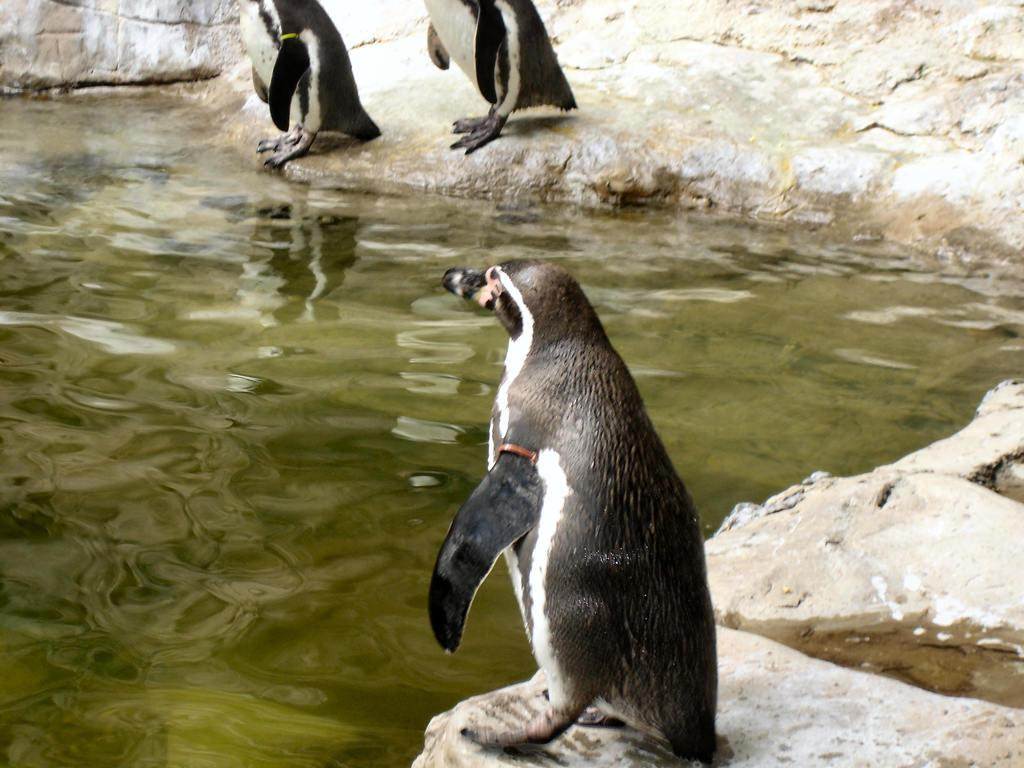How many penguins are in the image? There are three penguins in the image. Where are the penguins located? The penguins are on rocks. What can be seen in the background of the image? There is water visible in the background of the image. What type of chairs can be seen in the image? There are no chairs present in the image; it features three penguins on rocks with water visible in the background. 